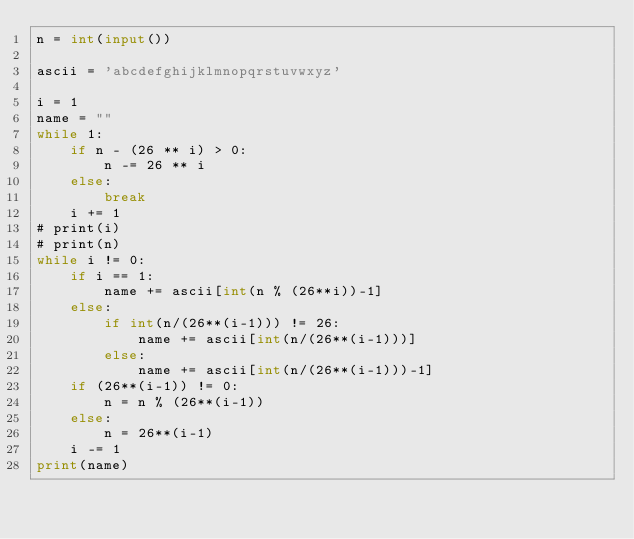Convert code to text. <code><loc_0><loc_0><loc_500><loc_500><_Python_>n = int(input())

ascii = 'abcdefghijklmnopqrstuvwxyz'

i = 1
name = ""
while 1:
    if n - (26 ** i) > 0:
        n -= 26 ** i
    else:
        break
    i += 1
# print(i)
# print(n)
while i != 0:
    if i == 1:
        name += ascii[int(n % (26**i))-1]
    else:
        if int(n/(26**(i-1))) != 26:
            name += ascii[int(n/(26**(i-1)))]
        else:
            name += ascii[int(n/(26**(i-1)))-1]
    if (26**(i-1)) != 0:
        n = n % (26**(i-1))
    else:
        n = 26**(i-1)
    i -= 1
print(name)
</code> 